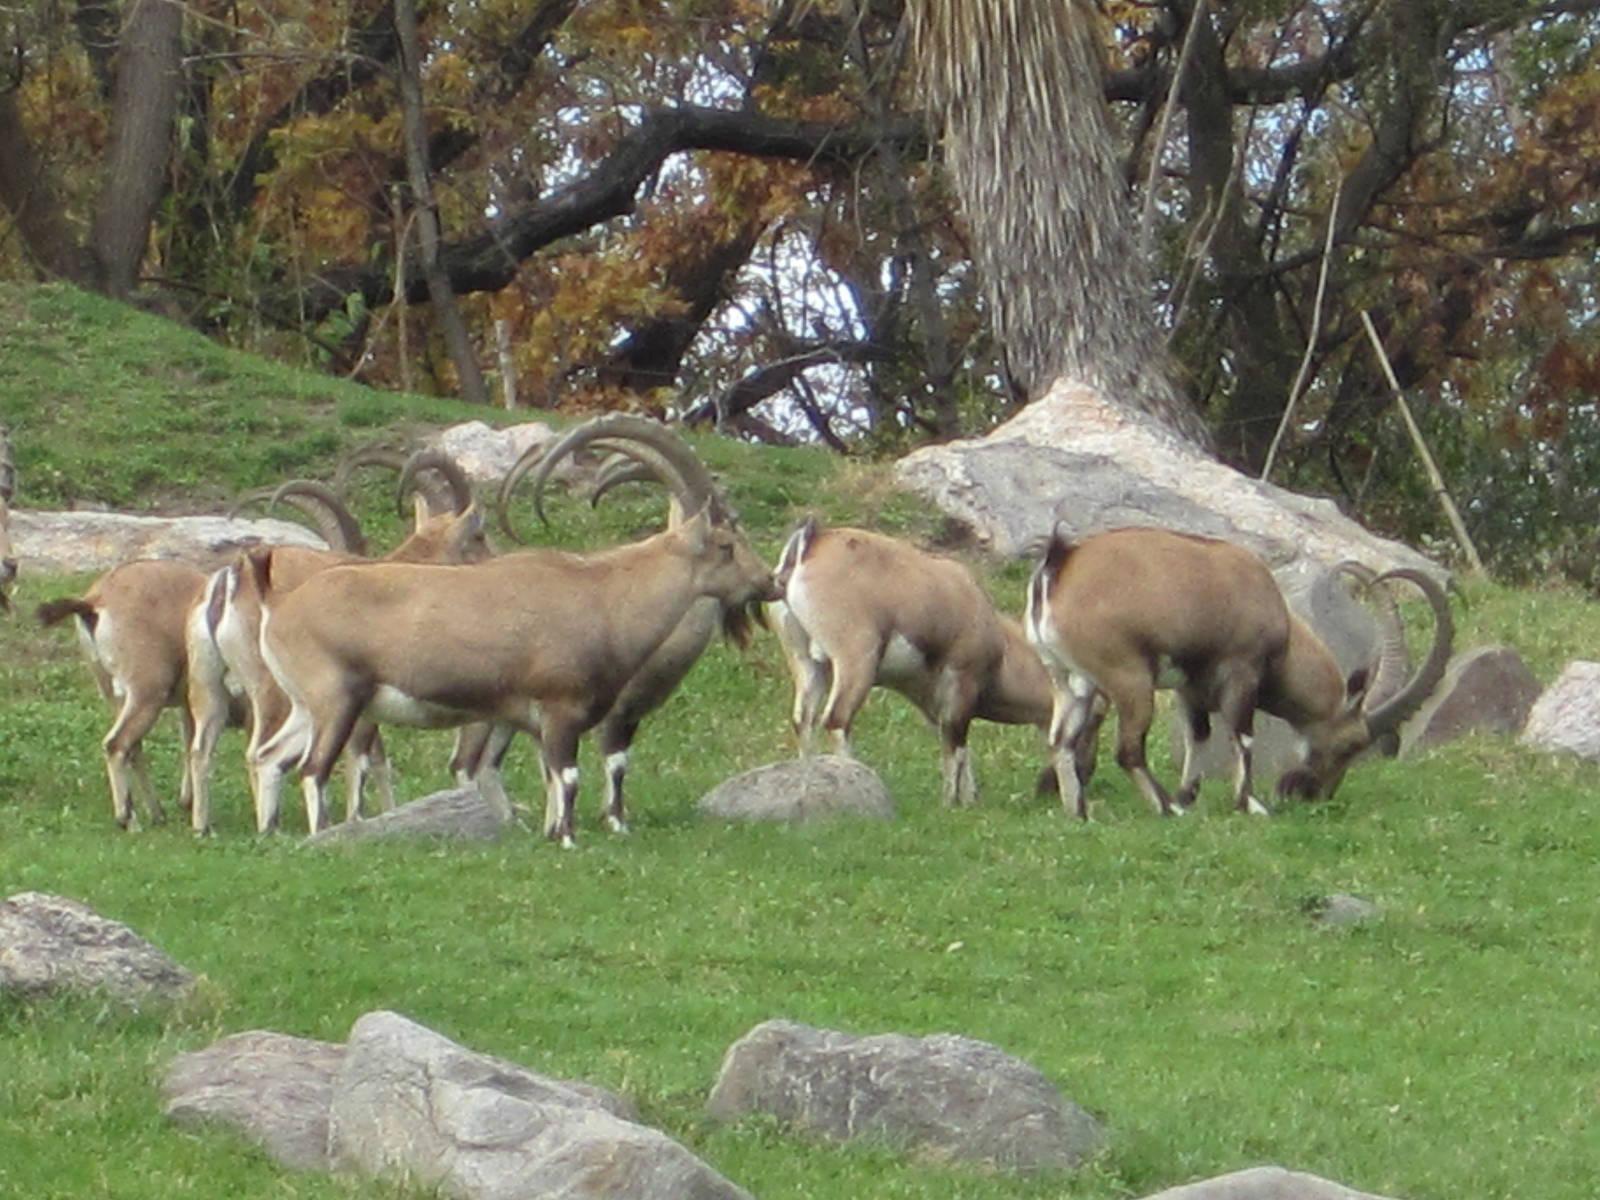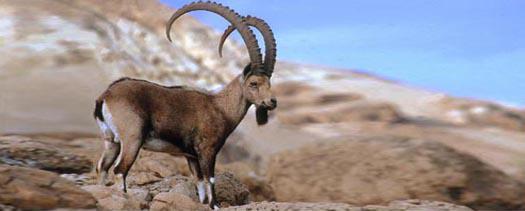The first image is the image on the left, the second image is the image on the right. Examine the images to the left and right. Is the description "An area of sky blue is visible behind at least one mountain." accurate? Answer yes or no. Yes. The first image is the image on the left, the second image is the image on the right. Examine the images to the left and right. Is the description "At least one antelope is standing on a rocky grassless mountain." accurate? Answer yes or no. Yes. 